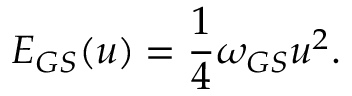<formula> <loc_0><loc_0><loc_500><loc_500>E _ { G S } ( u ) = \frac { 1 } { 4 } \omega _ { G S } u ^ { 2 } .</formula> 